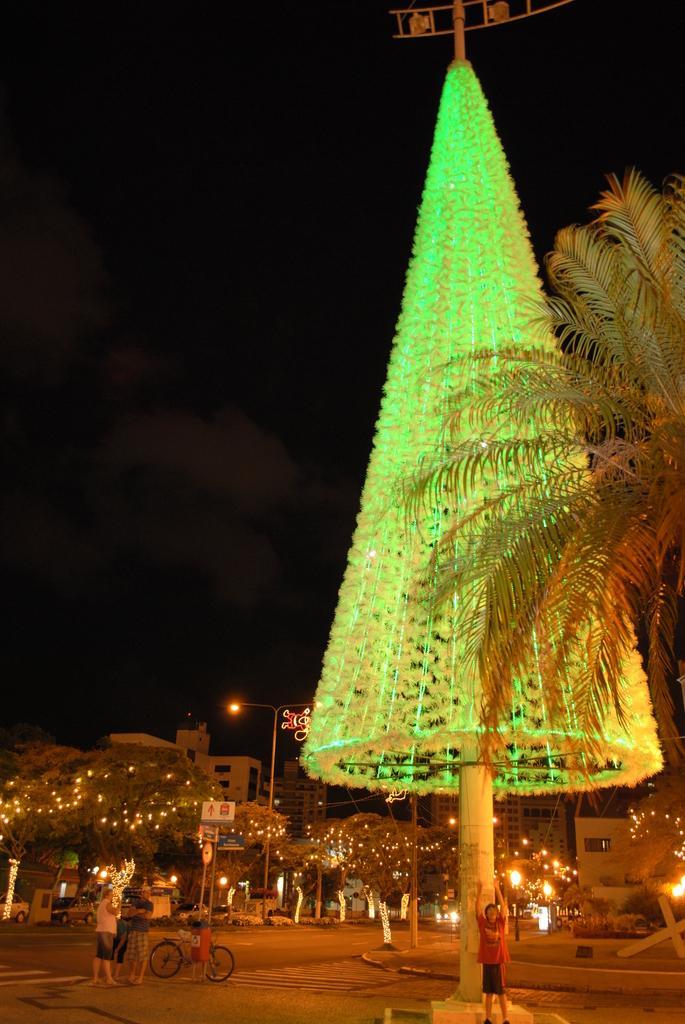Describe this image in one or two sentences. In the picture I can see a Christmas tree with lighting arrangement on the right side. There is a boy on the bottom right side. I can see three persons on the left side and I can see a bicycle on the road. In the background, I can see the buildings and light poles. I can see the trees with lighting arrangement. I can see the dark sky and there are clouds in the sky. 